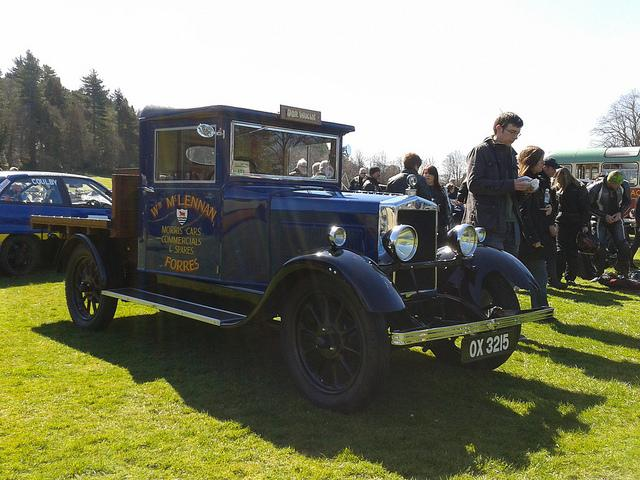What type of truck is shown? Please explain your reasoning. antique. The truck shown is at least 100 years old and is being shown because it is so old. 